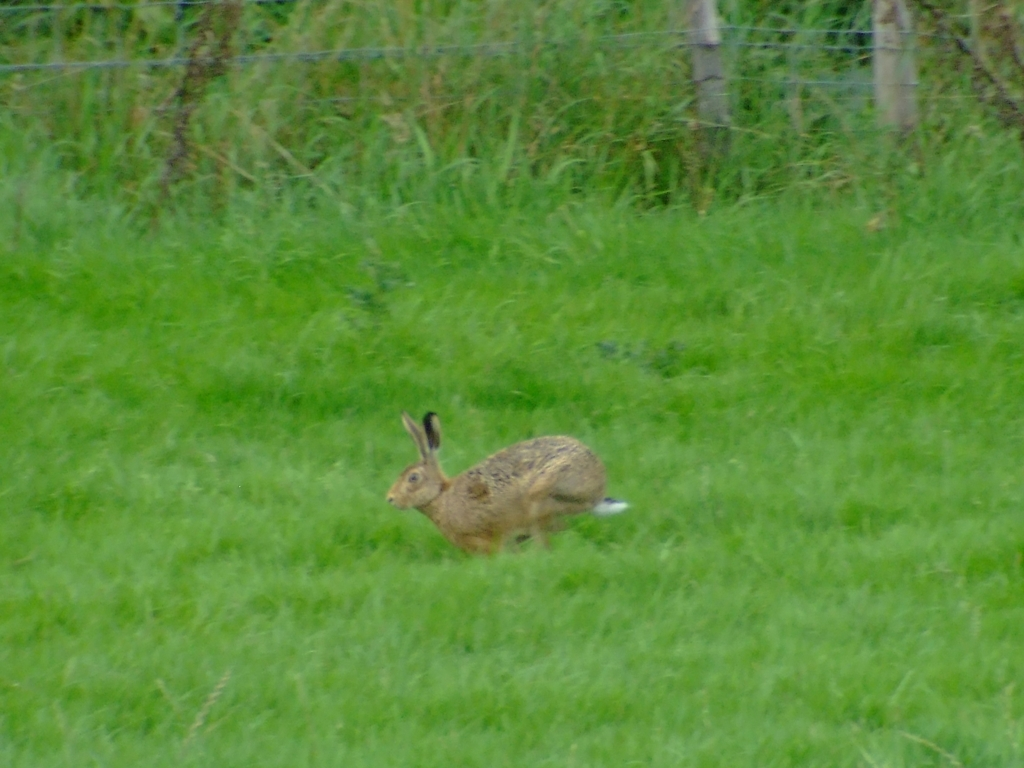Can you tell me what animal is pictured here, and does it appear to be in motion? The image captures a hare in the middle of a stride across a grassy field. You can tell from the position of its limbs and the blur surrounding its body that it is indeed in motion, most likely running at a quick pace. Is there any indication of the hare's habitat or the time of day? Judging by the natural environment and lighting, the hare seems to be in a rural or wild grassland habitat, which is typical for this species. The lighting suggests it may be overcast, making it difficult to determine the exact time of day with precision. 